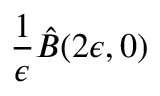Convert formula to latex. <formula><loc_0><loc_0><loc_500><loc_500>\frac { 1 } { \epsilon } \hat { B } ( 2 \epsilon , 0 )</formula> 